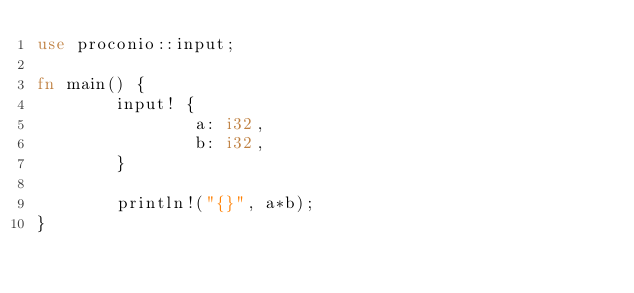<code> <loc_0><loc_0><loc_500><loc_500><_Rust_>use proconio::input;

fn main() {
        input! {
                a: i32,
                b: i32,
        }

        println!("{}", a*b);
}</code> 